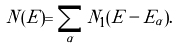Convert formula to latex. <formula><loc_0><loc_0><loc_500><loc_500>N ( E ) = \sum _ { \alpha } N _ { 1 } ( E - E _ { \alpha } ) .</formula> 